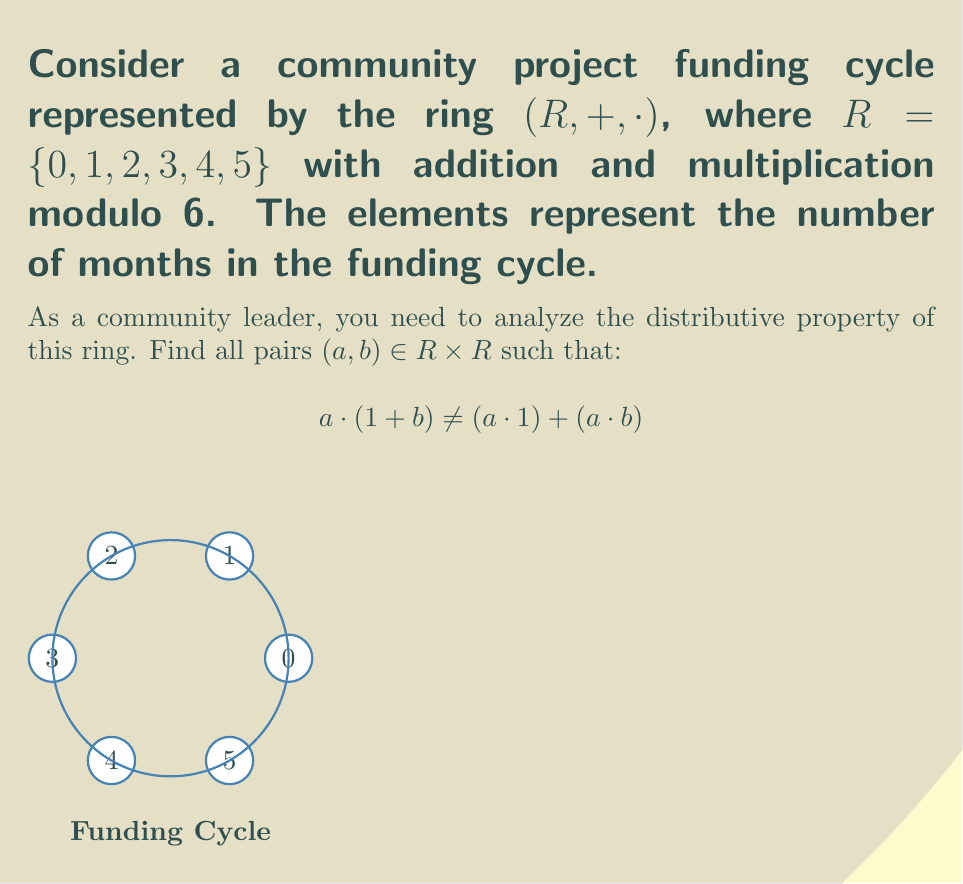Teach me how to tackle this problem. To solve this problem, we need to check the distributive property for all possible pairs $(a, b)$ in $R \times R$. We'll follow these steps:

1) For each pair $(a, b)$, calculate:
   - Left side: $a \cdot (1 + b)$
   - Right side: $(a \cdot 1) + (a \cdot b)$

2) Compare the results. If they're not equal, add the pair to our list.

3) Remember all operations are modulo 6.

Let's go through each pair:

For $a = 0$:
  All pairs $(0, b)$ satisfy the distributive property.

For $a = 1$:
  All pairs $(1, b)$ satisfy the distributive property.

For $a = 2$:
  $(2, 3)$: $2 \cdot (1 + 3) = 2 \cdot 4 = 2$, but $(2 \cdot 1) + (2 \cdot 3) = 2 + 0 = 2$
  All other pairs satisfy the property.

For $a = 3$:
  $(3, 1)$: $3 \cdot (1 + 1) = 3 \cdot 2 = 0$, but $(3 \cdot 1) + (3 \cdot 1) = 3 + 3 = 0$
  $(3, 3)$: $3 \cdot (1 + 3) = 3 \cdot 4 = 0$, but $(3 \cdot 1) + (3 \cdot 3) = 3 + 3 = 0$
  $(3, 5)$: $3 \cdot (1 + 5) = 3 \cdot 0 = 0$, but $(3 \cdot 1) + (3 \cdot 5) = 3 + 3 = 0$

For $a = 4$:
  $(4, 3)$: $4 \cdot (1 + 3) = 4 \cdot 4 = 4$, but $(4 \cdot 1) + (4 \cdot 3) = 4 + 0 = 4$
  All other pairs satisfy the property.

For $a = 5$:
  All pairs $(5, b)$ satisfy the distributive property.

Therefore, the pairs that do not satisfy the distributive property are:
$(2, 3)$, $(3, 1)$, $(3, 3)$, $(3, 5)$, and $(4, 3)$.
Answer: $\{(2, 3), (3, 1), (3, 3), (3, 5), (4, 3)\}$ 